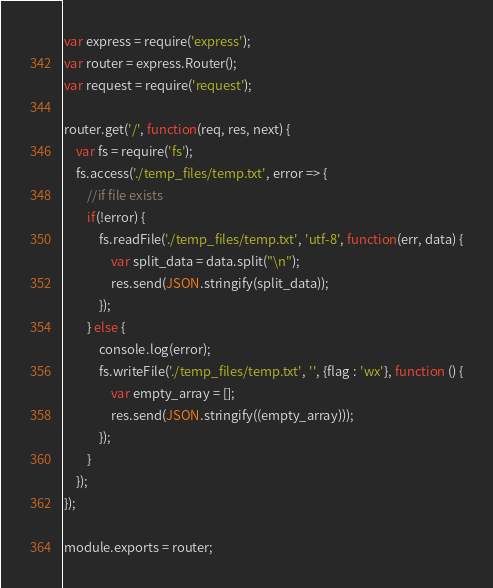Convert code to text. <code><loc_0><loc_0><loc_500><loc_500><_JavaScript_>var express = require('express');
var router = express.Router();
var request = require('request');

router.get('/', function(req, res, next) {
    var fs = require('fs');
    fs.access('./temp_files/temp.txt', error => {
        //if file exists
        if(!error) {
            fs.readFile('./temp_files/temp.txt', 'utf-8', function(err, data) {
                var split_data = data.split("\n");
                res.send(JSON.stringify(split_data));
            });
        } else {
            console.log(error);
            fs.writeFile('./temp_files/temp.txt', '', {flag : 'wx'}, function () {
                var empty_array = [];
                res.send(JSON.stringify((empty_array)));
            });
        }
    });
});

module.exports = router;</code> 